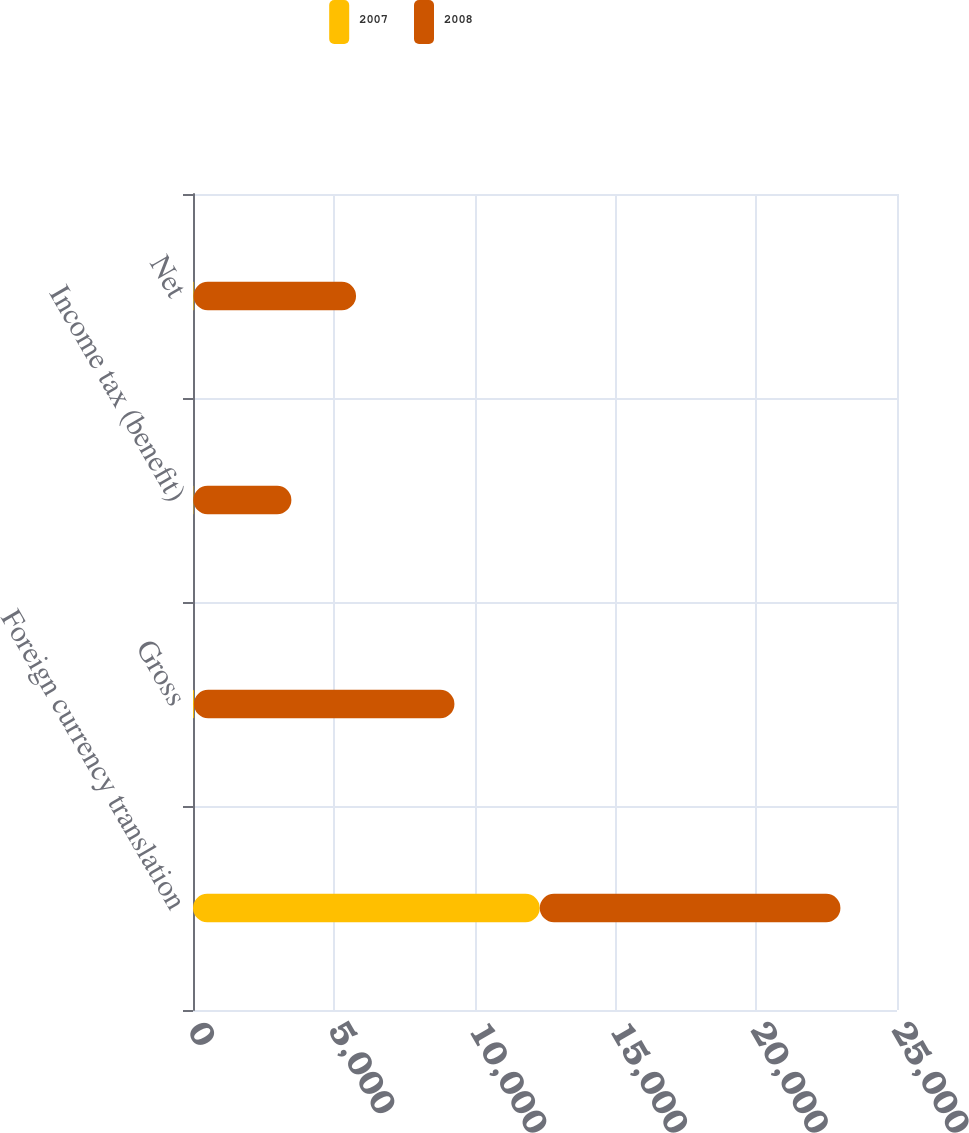Convert chart. <chart><loc_0><loc_0><loc_500><loc_500><stacked_bar_chart><ecel><fcel>Foreign currency translation<fcel>Gross<fcel>Income tax (benefit)<fcel>Net<nl><fcel>2007<fcel>12314<fcel>32<fcel>12<fcel>20<nl><fcel>2008<fcel>10677<fcel>9252<fcel>3482<fcel>5770<nl></chart> 